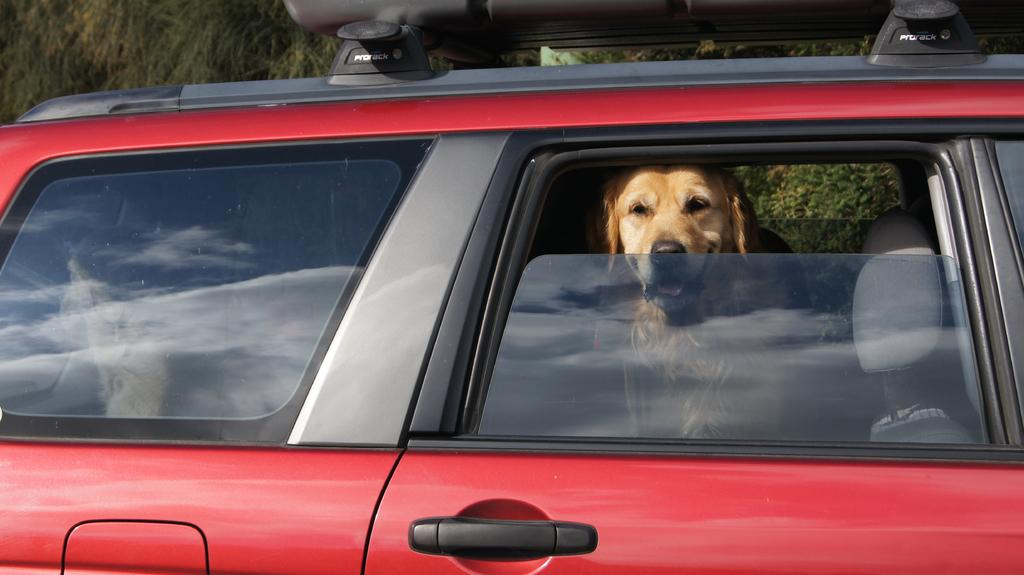What can be seen in the background of the image? There are trees in the background of the image. What animal is present in the image? There is a dog in the image. Where is the dog located in the image? The dog is sitting inside a red-colored car. What adjustments does the dog make to its mind while sitting in the car? The image does not provide information about the dog's mental state or any adjustments it might be making. 